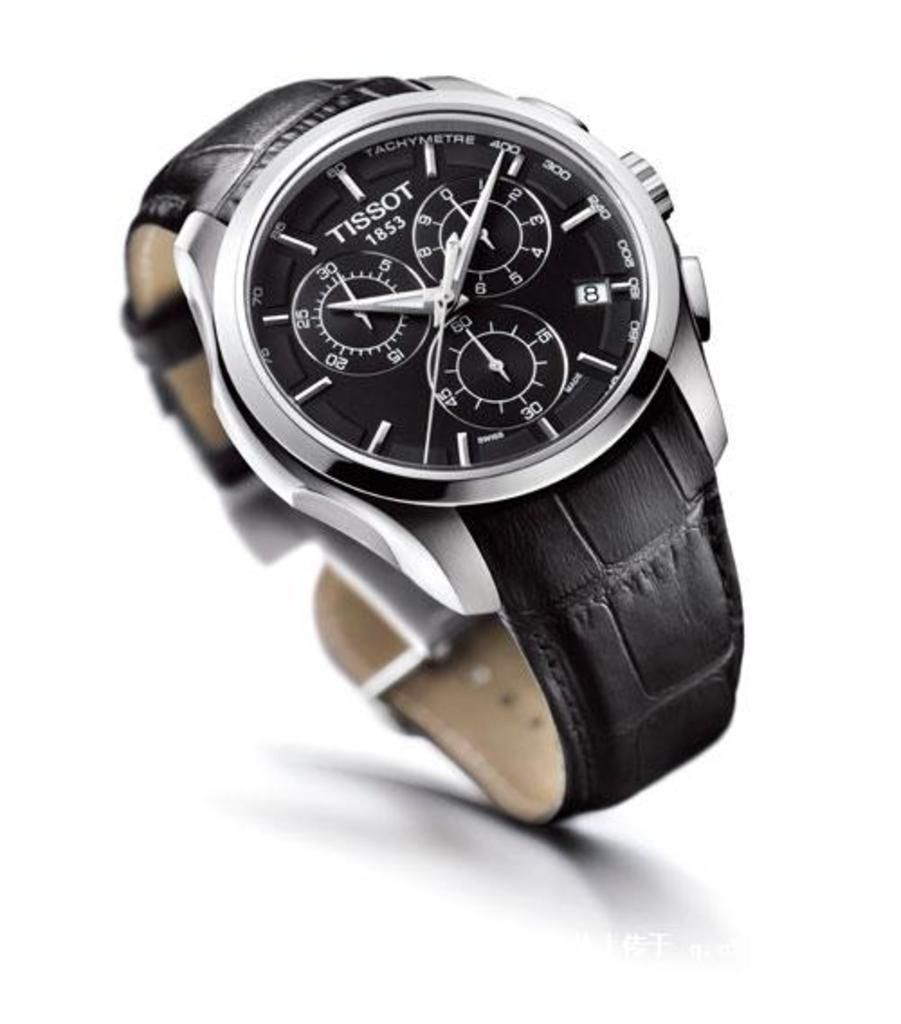<image>
Describe the image concisely. the tissot watch is black and silver with a leather band 